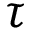Convert formula to latex. <formula><loc_0><loc_0><loc_500><loc_500>\tau</formula> 